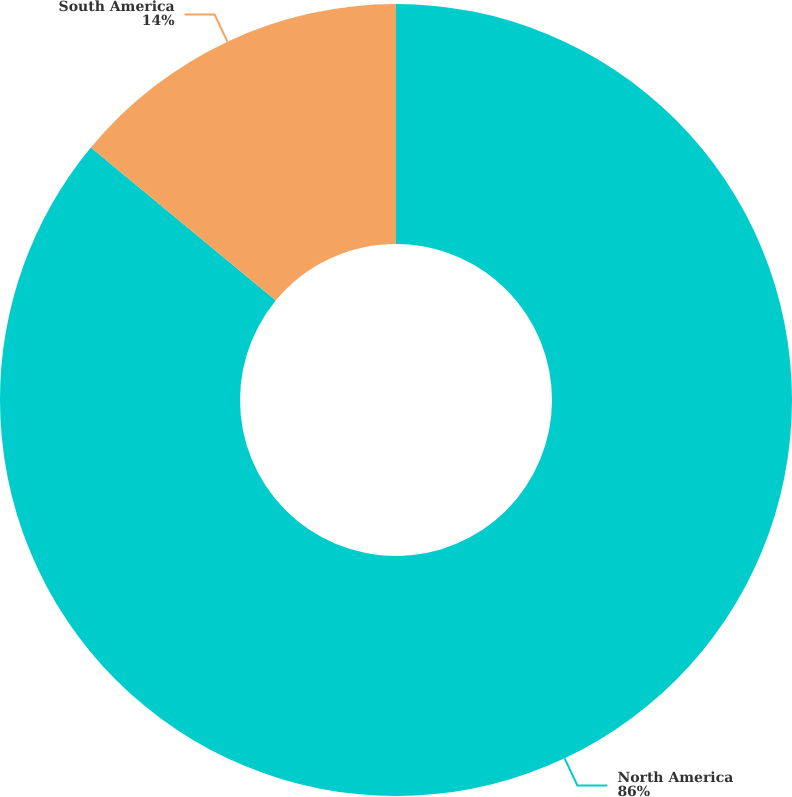<chart> <loc_0><loc_0><loc_500><loc_500><pie_chart><fcel>North America<fcel>South America<nl><fcel>86.0%<fcel>14.0%<nl></chart> 